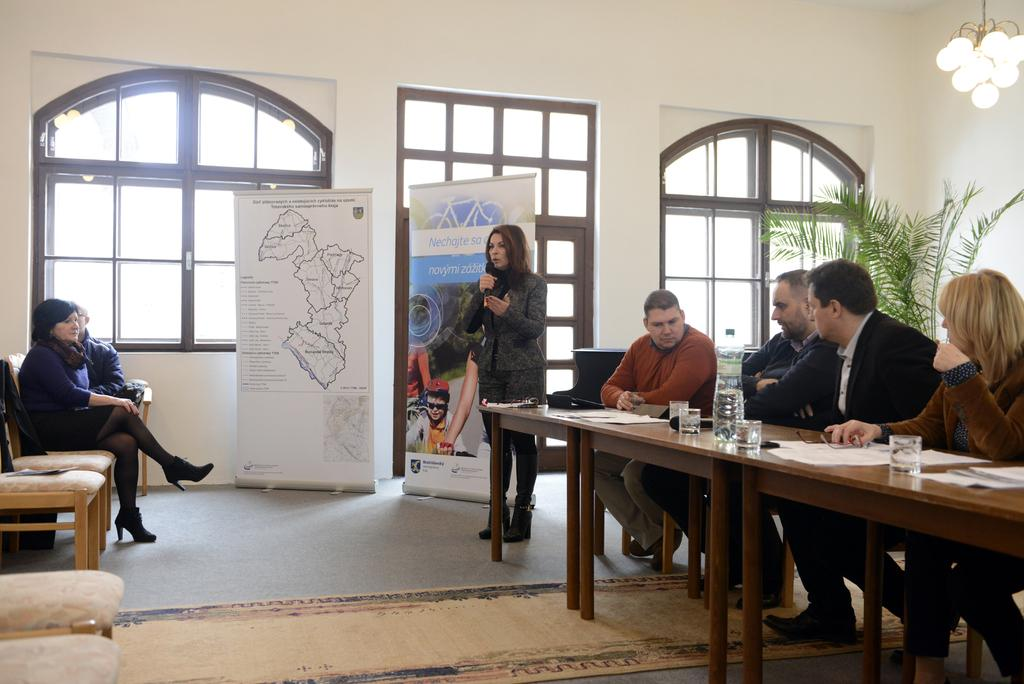How many people are in the image? There are people in the image, but the exact number is not specified. Can you describe the woman in the image? A woman is standing among the people in the image. What is on the table in the image? There are glasses and a water bottle on the table in the image. What can be seen in the background of the image? There is a plant and two banners in the background of the image. Who is the creator of the surprise in the image? There is no mention of a surprise in the image, so it is not possible to determine who created it. 